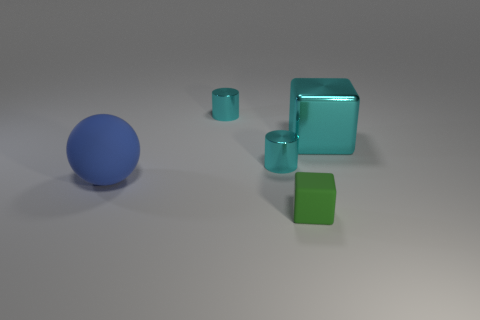What size is the cyan shiny block?
Your answer should be very brief. Large. Is the number of cylinders greater than the number of brown rubber cylinders?
Provide a short and direct response. Yes. What is the size of the blue ball to the left of the object to the right of the green rubber object?
Your answer should be very brief. Large. There is a matte object that is the same size as the metallic cube; what is its shape?
Keep it short and to the point. Sphere. What is the shape of the large thing that is behind the large object that is in front of the cube that is on the right side of the small green matte object?
Your response must be concise. Cube. Do the cube right of the small green cube and the metallic cylinder behind the cyan metal block have the same color?
Your answer should be very brief. Yes. How many large matte spheres are there?
Provide a short and direct response. 1. There is a big cyan object; are there any small cylinders behind it?
Make the answer very short. Yes. Do the green block that is to the left of the big metallic thing and the big thing on the left side of the small green block have the same material?
Your answer should be compact. Yes. Are there fewer small green things that are behind the small green rubber object than big objects?
Offer a very short reply. Yes. 